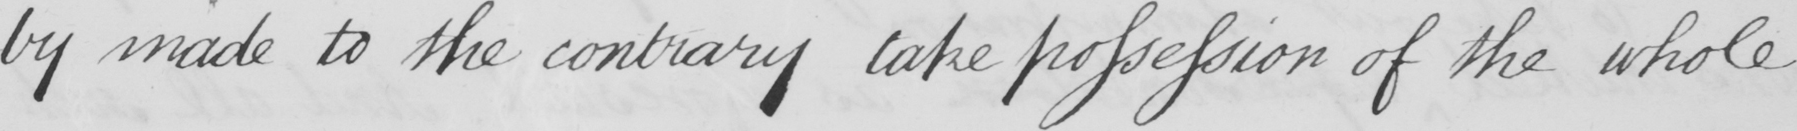What is written in this line of handwriting? -by made to the contray take possession of the whole 